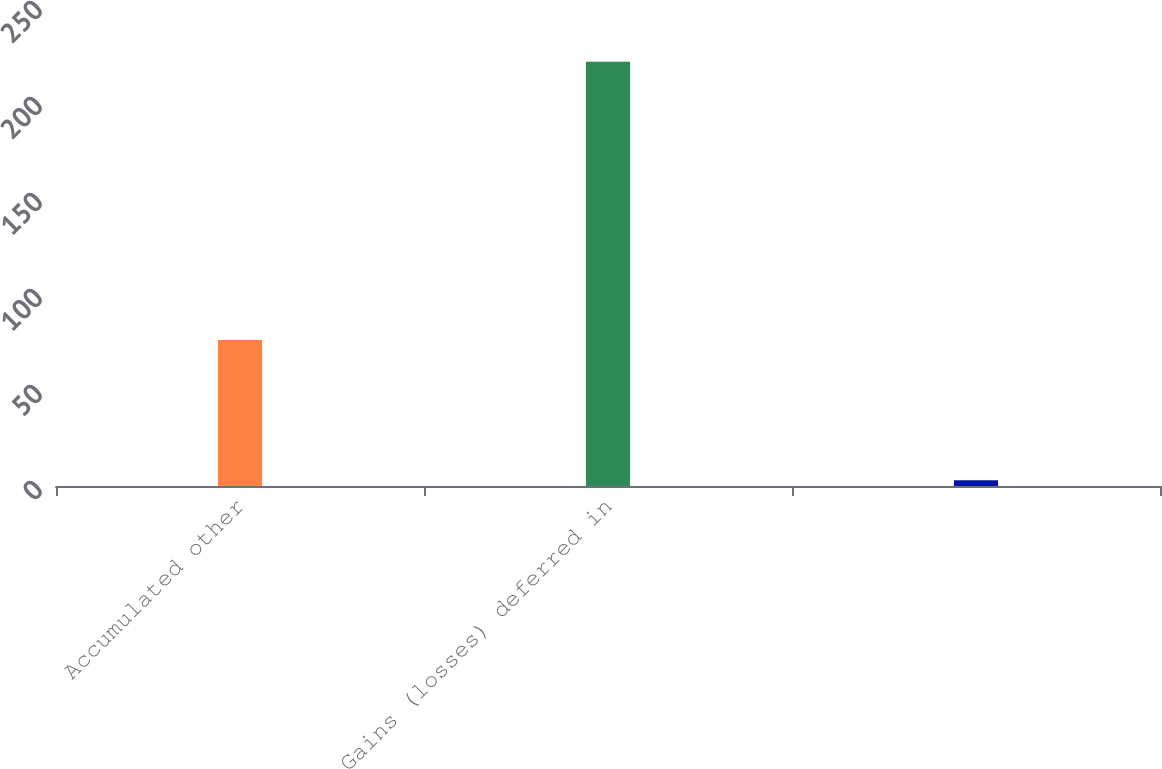Convert chart. <chart><loc_0><loc_0><loc_500><loc_500><bar_chart><fcel>Accumulated other<fcel>Gains (losses) deferred in<fcel>Unnamed: 2<nl><fcel>76<fcel>221<fcel>3<nl></chart> 